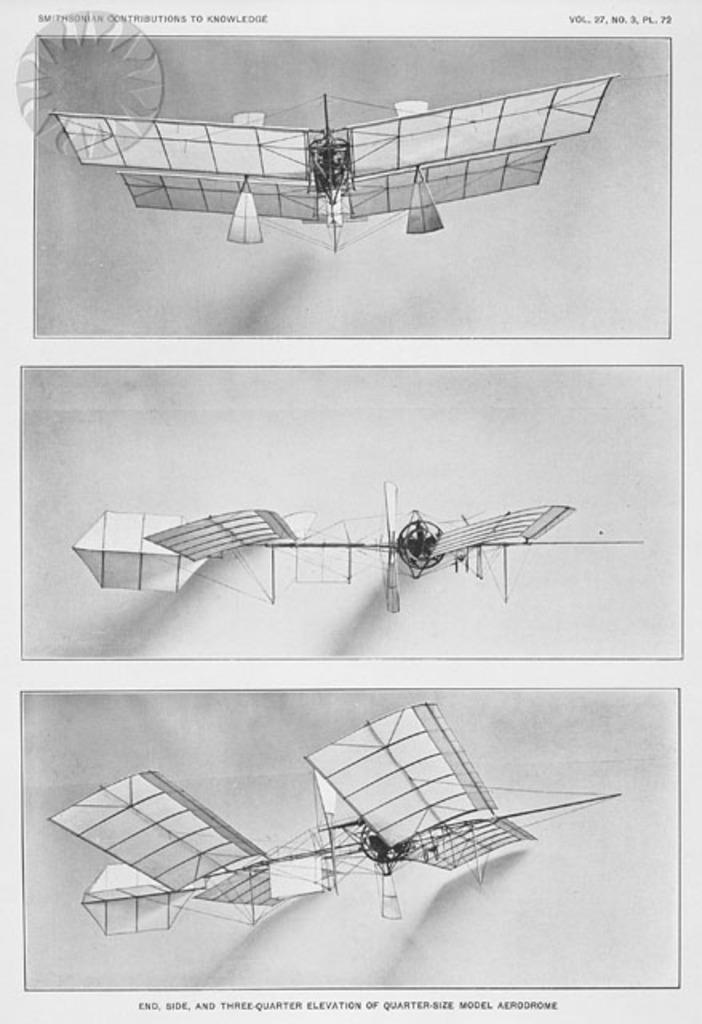Provide a one-sentence caption for the provided image. An exhibit of an early airplane design is seen in three photos on a Smithsonian handout. 